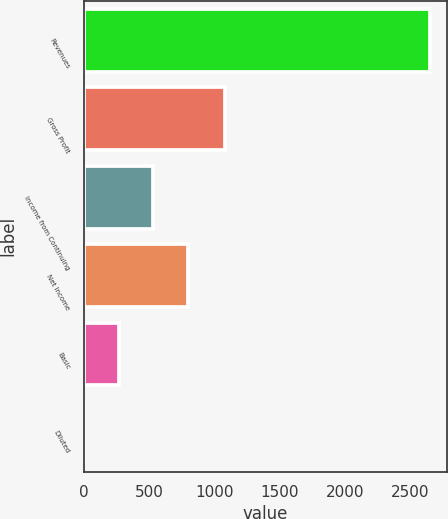<chart> <loc_0><loc_0><loc_500><loc_500><bar_chart><fcel>Revenues<fcel>Gross Profit<fcel>Income from Continuing<fcel>Net Income<fcel>Basic<fcel>Diluted<nl><fcel>2649<fcel>1083<fcel>530.25<fcel>795.09<fcel>265.41<fcel>0.57<nl></chart> 